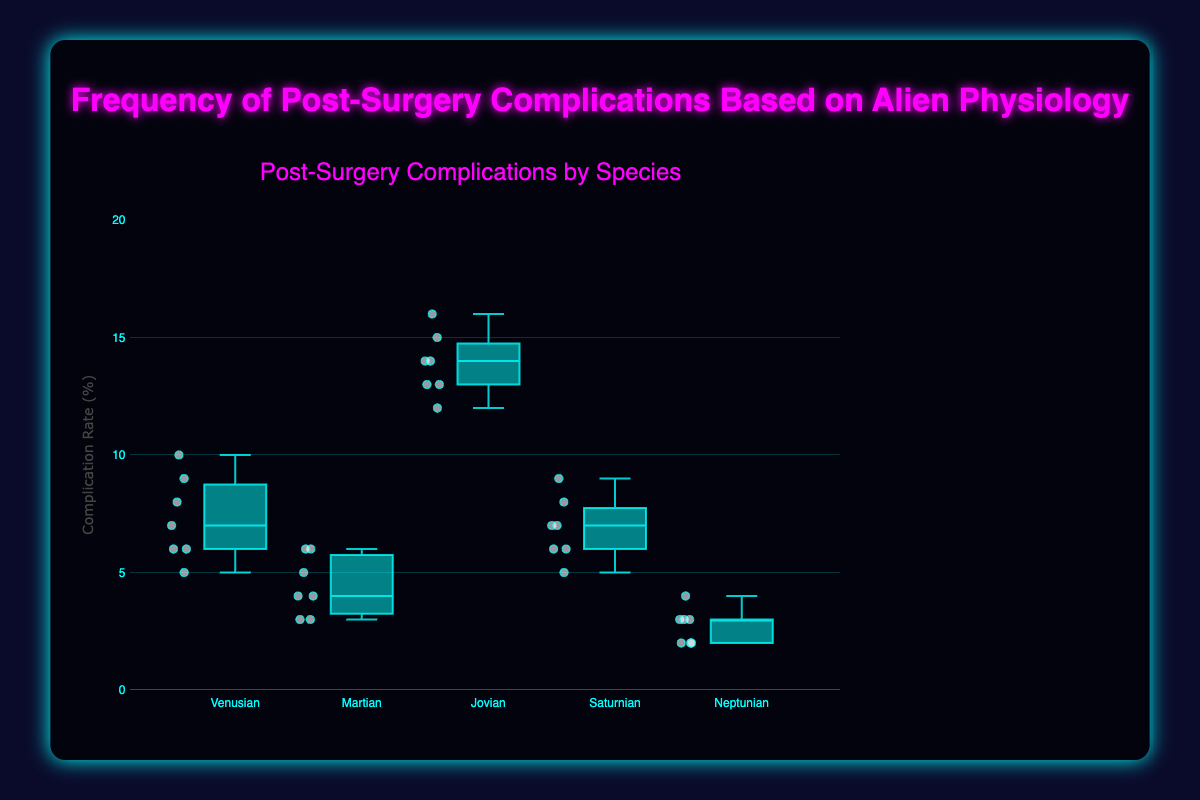Which species has the highest median complication rate? When observing median values in a box plot, the line inside the box represents the median. For the Jovians, this median line is the highest among all species.
Answer: Jovian What is the lower quartile (Q1) value for Martians? The lower quartile (Q1) in a box plot is the bottom edge of the box. For Martians, this value appears to be 3.
Answer: 3 Which species has the most variability in their complication rates? Variability is shown by the interquartile range (IQR), which is the distance between the bottom and top of the box. Jovians exhibit the widest box indicating the most variability.
Answer: Jovian What is the minimum complication rate for Neptunians? Minimum values are represented by the bottom whisker end in a box plot. The bottom whisker for Neptunians extends to 2.
Answer: 2 Do any species have outliers in their complication rates? If so, which? Outliers are typically indicated by individual points outside the whiskers of a box plot. In this plot, there are no data points significantly outside any whiskers, meaning no species have outliers here.
Answer: No How does the maximum complication rate for Venusians compare to that for Martians? The maximum rate is the top whisker or the highest point for each species. For Venusians, the top whisker reaches up to 10, whereas for Martians, it is 6. 10 is greater than 6, so Venusians have a higher maximum complication rate than Martians.
Answer: Venusians have a higher maximum What is the interquartile range (IQR) for Saturnians? The IQR is calculated by subtracting the lower quartile (Q1) from the upper quartile (Q3). For Saturnians, Q1 is 6 and Q3 is 8, making the IQR 8 - 6 = 2.
Answer: 2 Which species has the lowest median complication rate? By examining the line inside each box (median line), Neptunians have the lowest median value.
Answer: Neptunian What is the range of complication rates for Jovians? The range is found by subtracting the minimum value (bottom whisker) from the maximum value (top whisker). For Jovians, minimum = 12 and maximum = 16, hence the range is 16 - 12 = 4.
Answer: 4 How does the upper quartile (Q3) for Venusians compare to that for Saturnians? The upper quartile (Q3) is the top edge of the box. The Venusian Q3 is at 8, while the Saturnian Q3 is also at 8, meaning they are equal.
Answer: Equal 